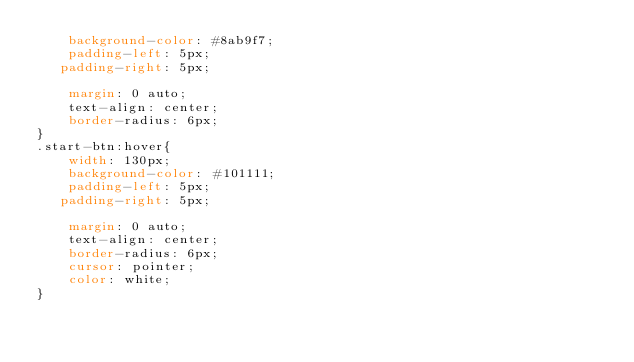Convert code to text. <code><loc_0><loc_0><loc_500><loc_500><_CSS_>    background-color: #8ab9f7;
    padding-left: 5px;
   padding-right: 5px;
    
    margin: 0 auto;
    text-align: center;
    border-radius: 6px;
}
.start-btn:hover{
    width: 130px;
    background-color: #101111;
    padding-left: 5px;
   padding-right: 5px;
    
    margin: 0 auto;
    text-align: center;
    border-radius: 6px;
    cursor: pointer;
    color: white;
}
</code> 